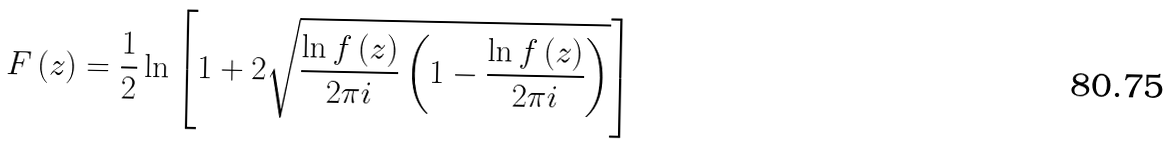Convert formula to latex. <formula><loc_0><loc_0><loc_500><loc_500>F \left ( z \right ) = \frac { 1 } { 2 } \ln \left [ 1 + 2 \sqrt { \frac { \ln f \left ( z \right ) } { 2 \pi i } \left ( 1 - \frac { \ln f \left ( z \right ) } { 2 \pi i } \right ) } \right ]</formula> 